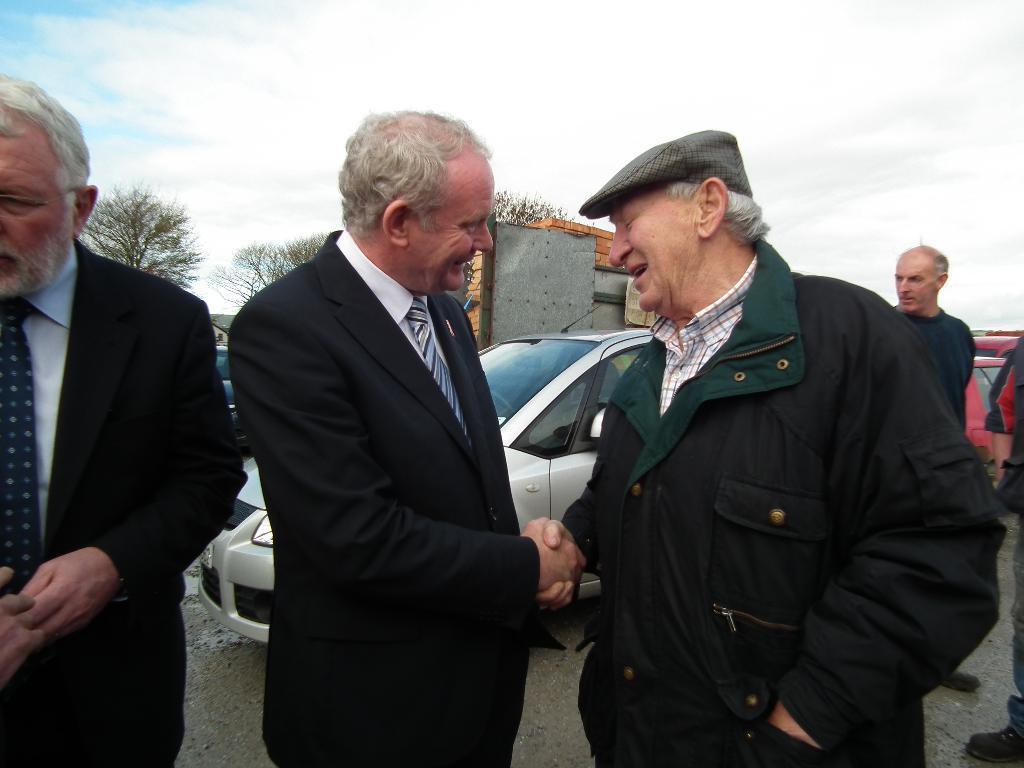Can you describe this image briefly? In this image we can see men standing on the road and some of them are smiling. In the background there are motor vehicles on the road, buildings, trees and sky with clouds. 